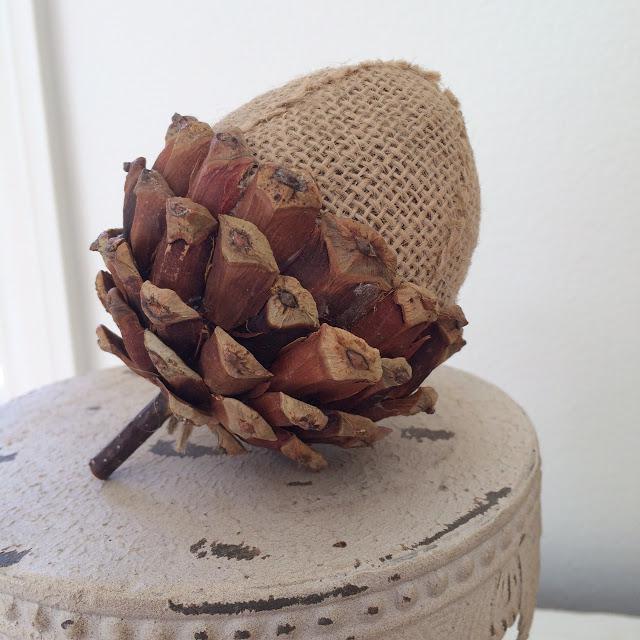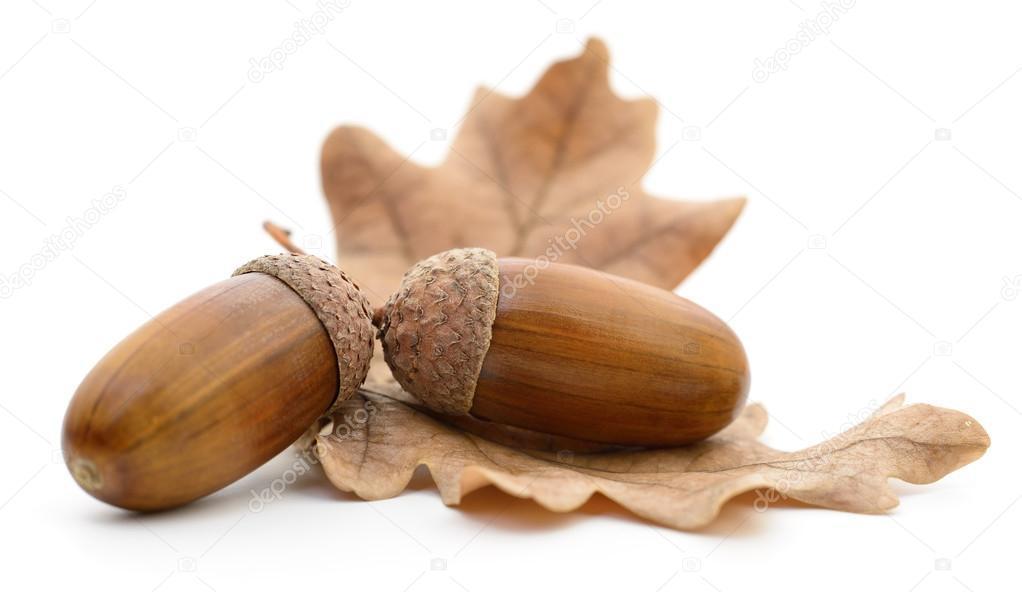The first image is the image on the left, the second image is the image on the right. For the images displayed, is the sentence "The left image contains exactly three brown acorns with their caps on." factually correct? Answer yes or no. No. 